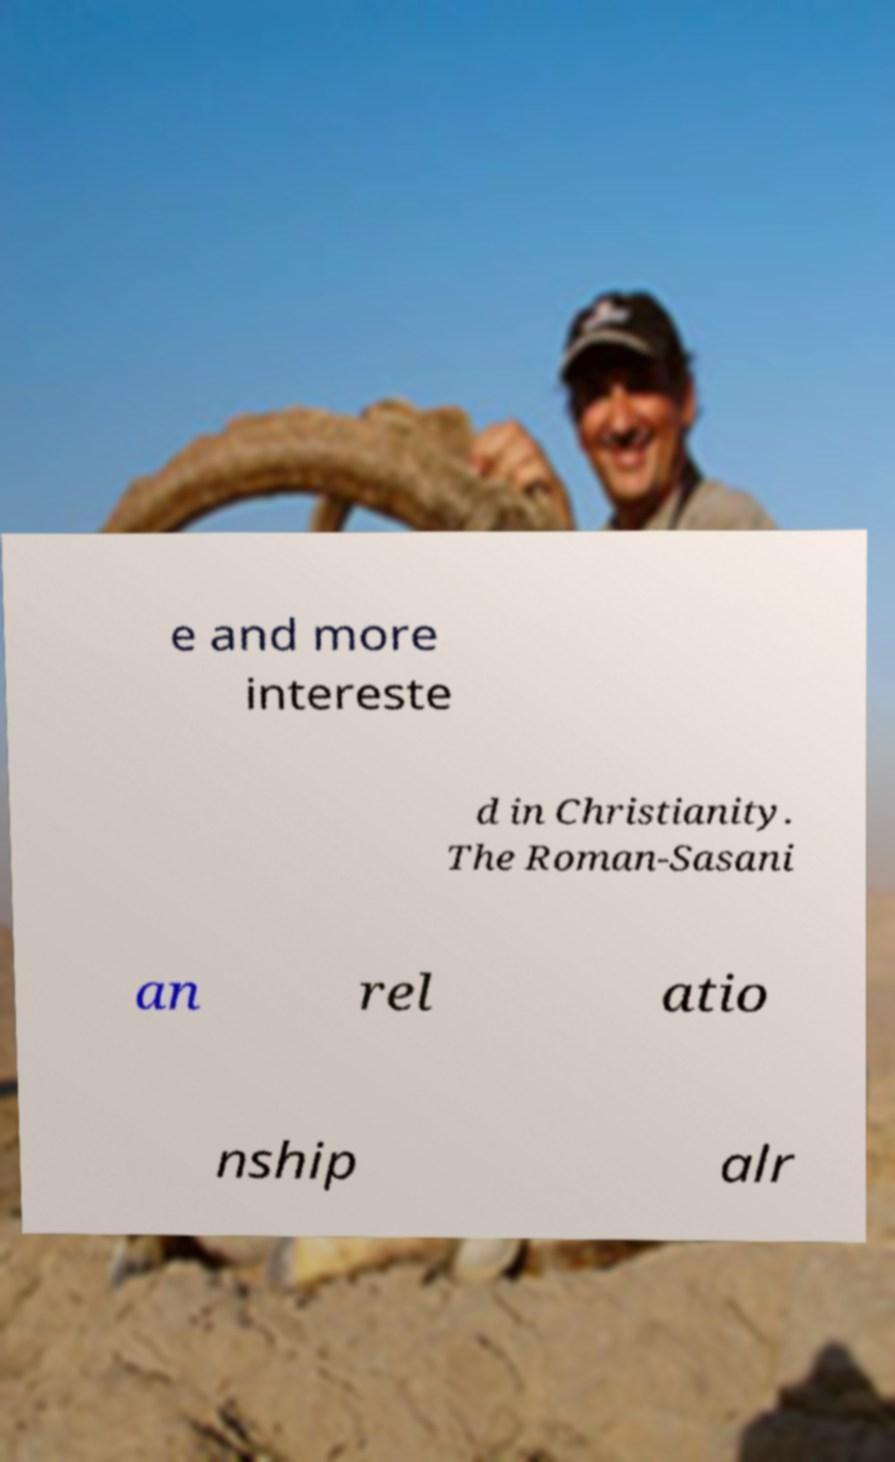Can you read and provide the text displayed in the image?This photo seems to have some interesting text. Can you extract and type it out for me? e and more intereste d in Christianity. The Roman-Sasani an rel atio nship alr 